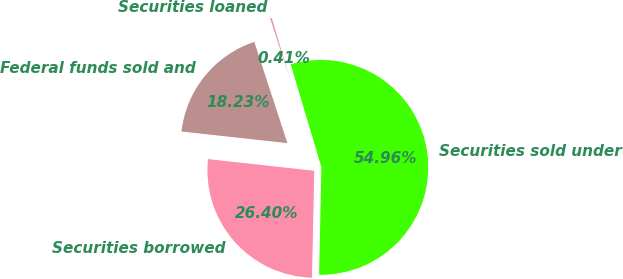<chart> <loc_0><loc_0><loc_500><loc_500><pie_chart><fcel>Federal funds sold and<fcel>Securities borrowed<fcel>Securities sold under<fcel>Securities loaned<nl><fcel>18.23%<fcel>26.4%<fcel>54.96%<fcel>0.41%<nl></chart> 